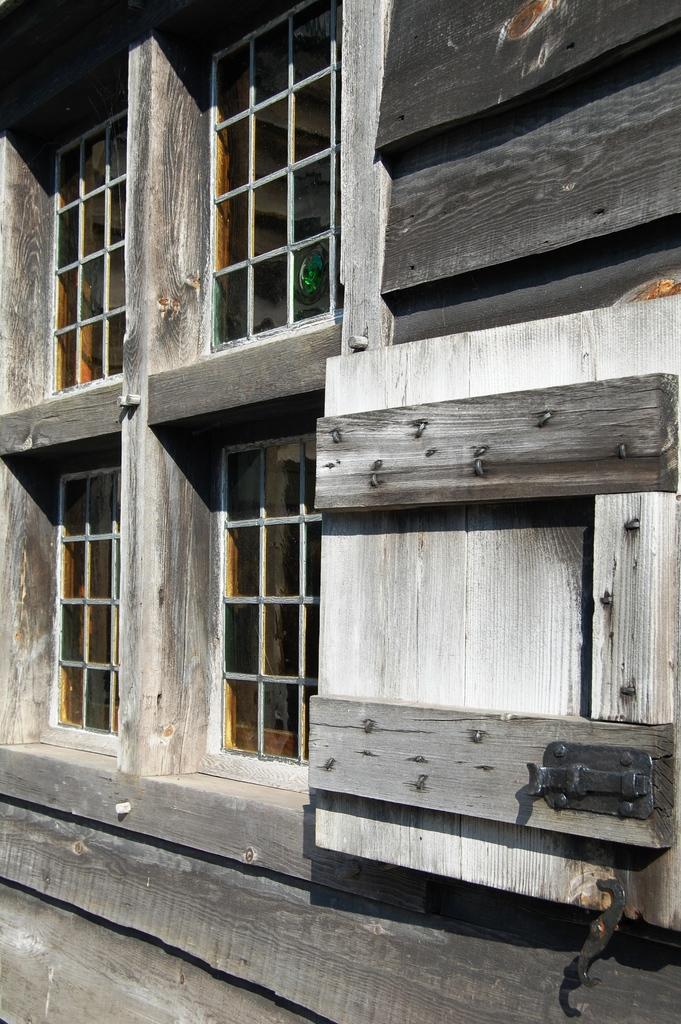How would you summarize this image in a sentence or two? In this image we can see a wooden wall of a building. On the buildings we can see few windows. 